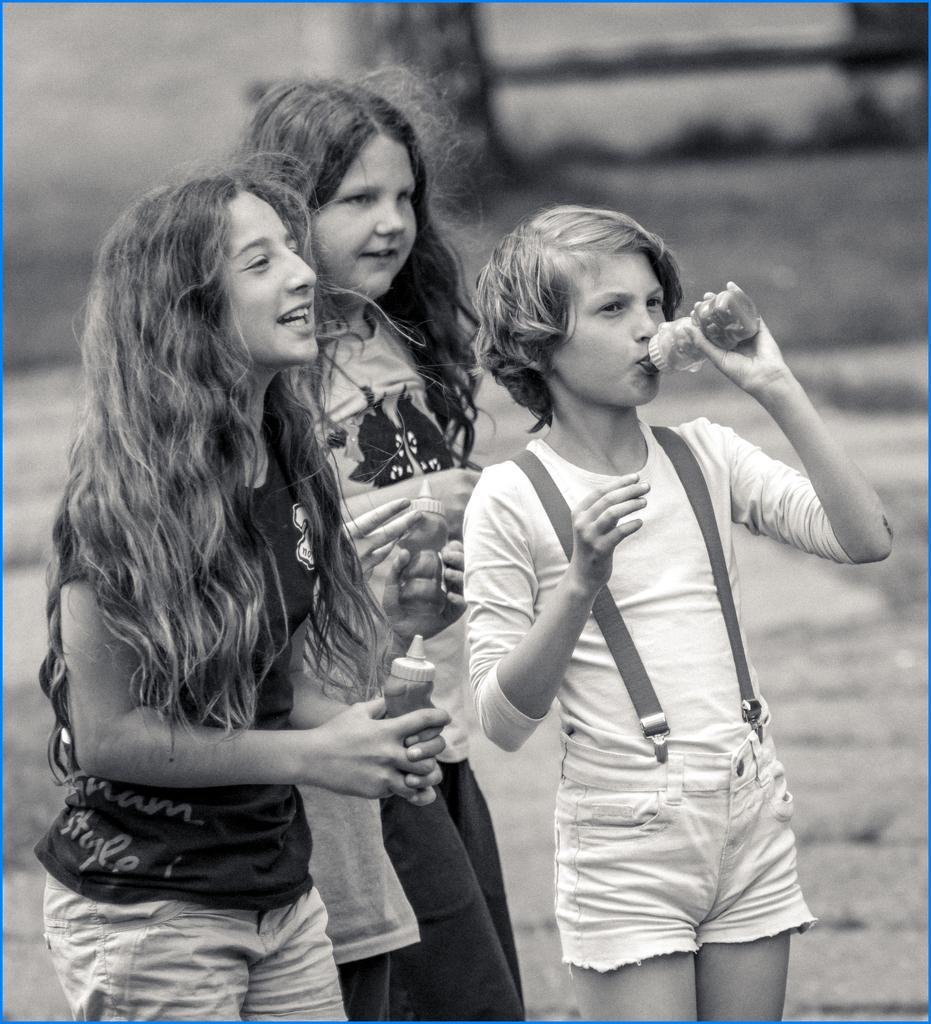How would you summarize this image in a sentence or two? This is a black and white pic. Here we can see kids are handing and they are holding bottles in their hands. In the background the image is blur. 